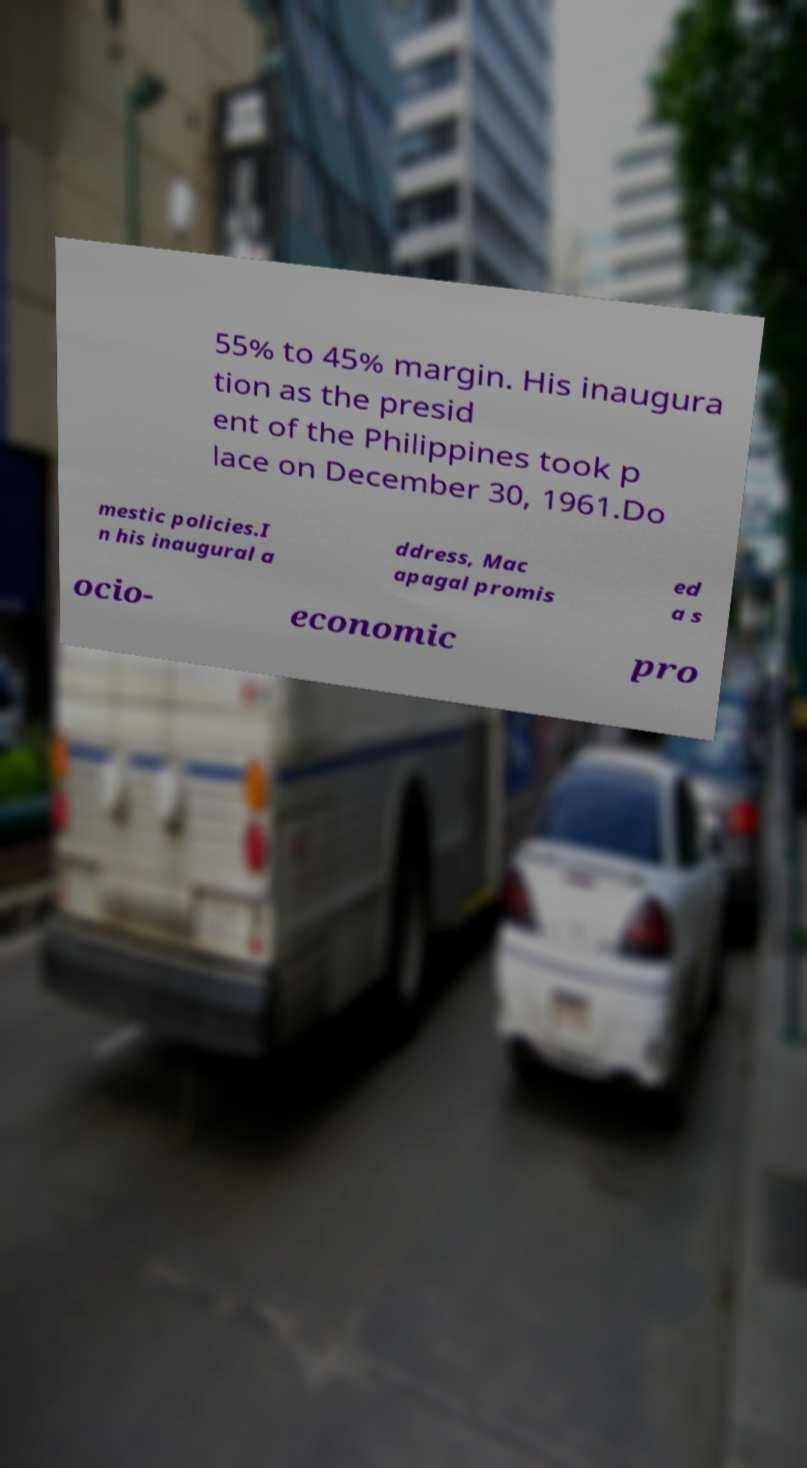What messages or text are displayed in this image? I need them in a readable, typed format. 55% to 45% margin. His inaugura tion as the presid ent of the Philippines took p lace on December 30, 1961.Do mestic policies.I n his inaugural a ddress, Mac apagal promis ed a s ocio- economic pro 